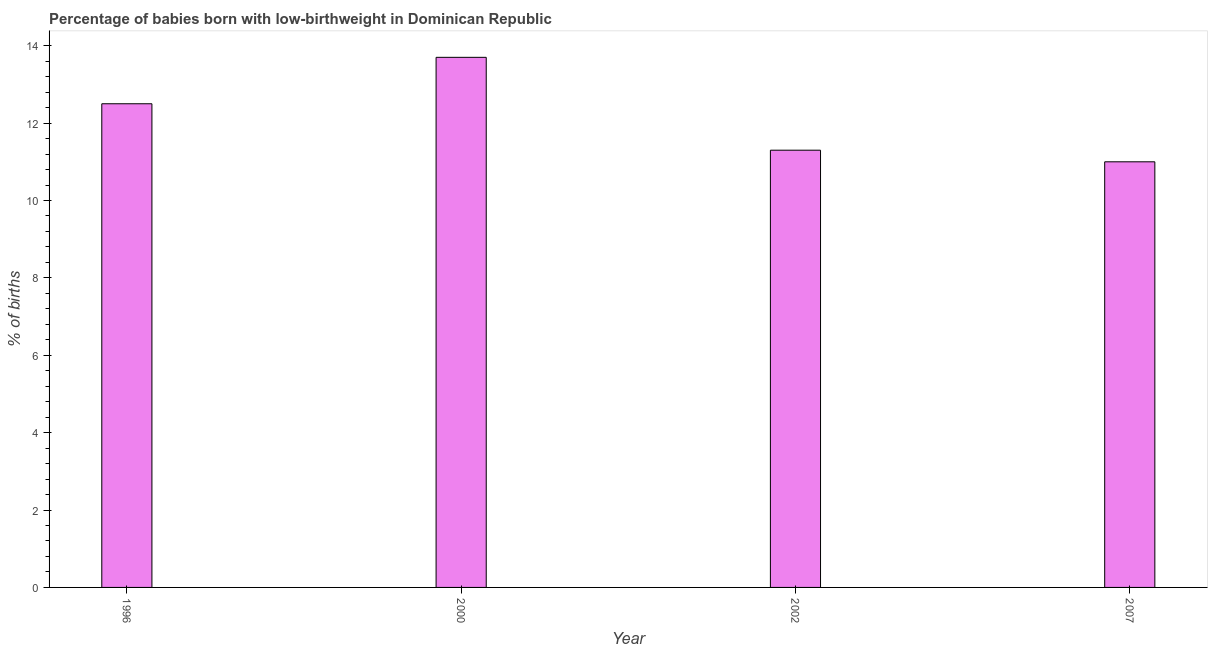Does the graph contain any zero values?
Your answer should be very brief. No. What is the title of the graph?
Your answer should be compact. Percentage of babies born with low-birthweight in Dominican Republic. What is the label or title of the X-axis?
Provide a short and direct response. Year. What is the label or title of the Y-axis?
Give a very brief answer. % of births. What is the percentage of babies who were born with low-birthweight in 2007?
Keep it short and to the point. 11. In which year was the percentage of babies who were born with low-birthweight maximum?
Your answer should be compact. 2000. In which year was the percentage of babies who were born with low-birthweight minimum?
Your answer should be compact. 2007. What is the sum of the percentage of babies who were born with low-birthweight?
Make the answer very short. 48.5. What is the difference between the percentage of babies who were born with low-birthweight in 2000 and 2007?
Provide a short and direct response. 2.7. What is the average percentage of babies who were born with low-birthweight per year?
Your answer should be very brief. 12.12. In how many years, is the percentage of babies who were born with low-birthweight greater than 12.8 %?
Offer a terse response. 1. Do a majority of the years between 2000 and 1996 (inclusive) have percentage of babies who were born with low-birthweight greater than 2.8 %?
Provide a short and direct response. No. What is the ratio of the percentage of babies who were born with low-birthweight in 2000 to that in 2007?
Give a very brief answer. 1.25. Is the percentage of babies who were born with low-birthweight in 2002 less than that in 2007?
Your answer should be very brief. No. What is the difference between the highest and the second highest percentage of babies who were born with low-birthweight?
Your response must be concise. 1.2. Is the sum of the percentage of babies who were born with low-birthweight in 2000 and 2007 greater than the maximum percentage of babies who were born with low-birthweight across all years?
Your answer should be very brief. Yes. In how many years, is the percentage of babies who were born with low-birthweight greater than the average percentage of babies who were born with low-birthweight taken over all years?
Offer a terse response. 2. How many bars are there?
Provide a succinct answer. 4. Are all the bars in the graph horizontal?
Your answer should be very brief. No. How many years are there in the graph?
Provide a short and direct response. 4. What is the difference between two consecutive major ticks on the Y-axis?
Keep it short and to the point. 2. Are the values on the major ticks of Y-axis written in scientific E-notation?
Ensure brevity in your answer.  No. What is the % of births of 1996?
Provide a short and direct response. 12.5. What is the % of births of 2000?
Your answer should be compact. 13.7. What is the % of births of 2002?
Ensure brevity in your answer.  11.3. What is the difference between the % of births in 1996 and 2007?
Make the answer very short. 1.5. What is the difference between the % of births in 2000 and 2002?
Offer a terse response. 2.4. What is the difference between the % of births in 2000 and 2007?
Provide a short and direct response. 2.7. What is the ratio of the % of births in 1996 to that in 2000?
Ensure brevity in your answer.  0.91. What is the ratio of the % of births in 1996 to that in 2002?
Ensure brevity in your answer.  1.11. What is the ratio of the % of births in 1996 to that in 2007?
Make the answer very short. 1.14. What is the ratio of the % of births in 2000 to that in 2002?
Keep it short and to the point. 1.21. What is the ratio of the % of births in 2000 to that in 2007?
Your answer should be compact. 1.25. 